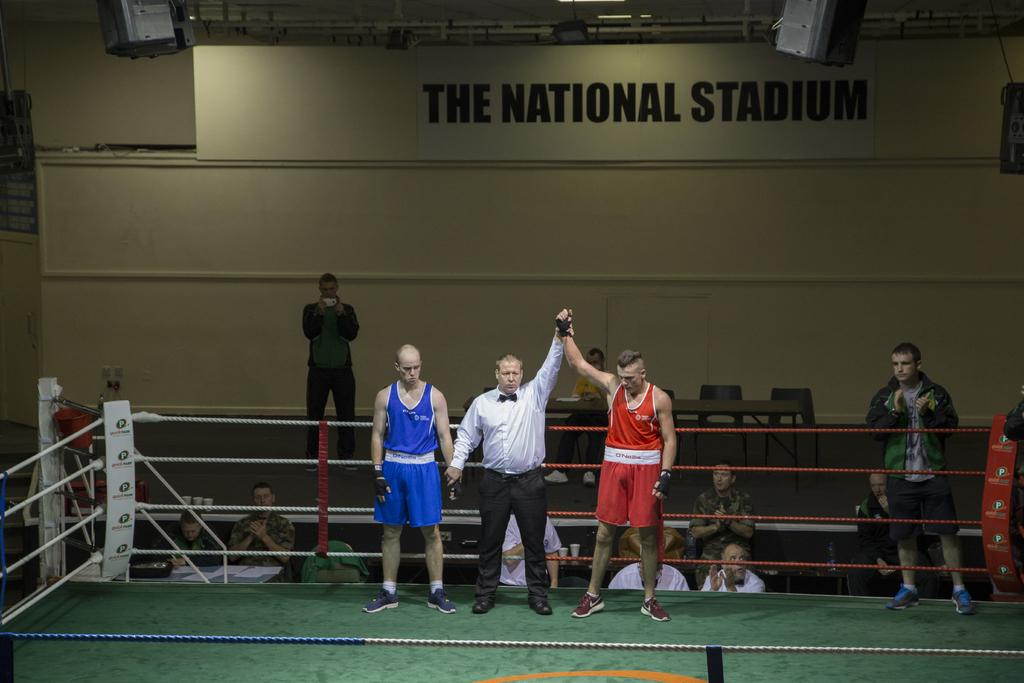<image>
Describe the image concisely. A winning boxer is declared at The National Stadium. 